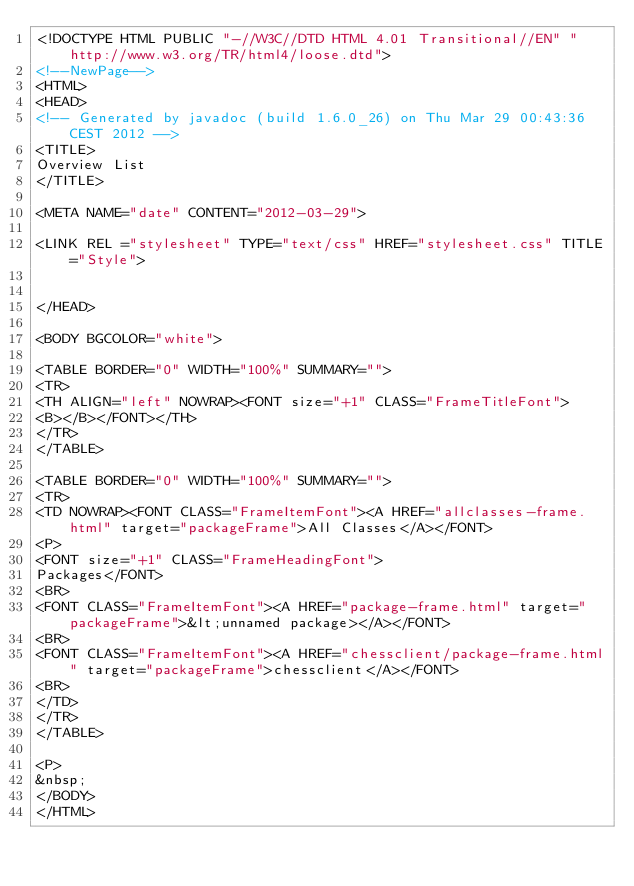Convert code to text. <code><loc_0><loc_0><loc_500><loc_500><_HTML_><!DOCTYPE HTML PUBLIC "-//W3C//DTD HTML 4.01 Transitional//EN" "http://www.w3.org/TR/html4/loose.dtd">
<!--NewPage-->
<HTML>
<HEAD>
<!-- Generated by javadoc (build 1.6.0_26) on Thu Mar 29 00:43:36 CEST 2012 -->
<TITLE>
Overview List
</TITLE>

<META NAME="date" CONTENT="2012-03-29">

<LINK REL ="stylesheet" TYPE="text/css" HREF="stylesheet.css" TITLE="Style">


</HEAD>

<BODY BGCOLOR="white">

<TABLE BORDER="0" WIDTH="100%" SUMMARY="">
<TR>
<TH ALIGN="left" NOWRAP><FONT size="+1" CLASS="FrameTitleFont">
<B></B></FONT></TH>
</TR>
</TABLE>

<TABLE BORDER="0" WIDTH="100%" SUMMARY="">
<TR>
<TD NOWRAP><FONT CLASS="FrameItemFont"><A HREF="allclasses-frame.html" target="packageFrame">All Classes</A></FONT>
<P>
<FONT size="+1" CLASS="FrameHeadingFont">
Packages</FONT>
<BR>
<FONT CLASS="FrameItemFont"><A HREF="package-frame.html" target="packageFrame">&lt;unnamed package></A></FONT>
<BR>
<FONT CLASS="FrameItemFont"><A HREF="chessclient/package-frame.html" target="packageFrame">chessclient</A></FONT>
<BR>
</TD>
</TR>
</TABLE>

<P>
&nbsp;
</BODY>
</HTML>
</code> 